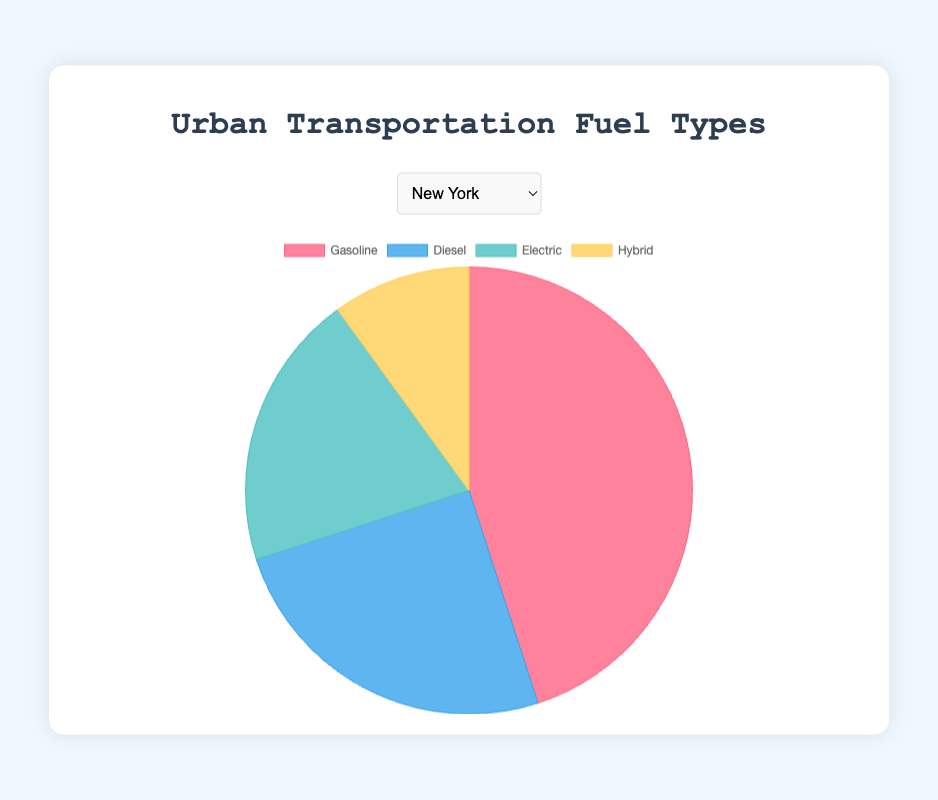Which city has the highest percentage of electric vehicles? By looking at the pie charts, we can observe the segment labeled "Electric." San Francisco has the highest percentage at 30%.
Answer: San Francisco Which city has the smallest proportion of diesel vehicles? By analyzing the pie charts, we see that the "Diesel" segment in San Francisco is the smallest at 10%.
Answer: San Francisco How does the percentage of hybrid vehicles in Los Angeles compare to that of New York? The Los Angeles pie chart shows 15% hybrid vehicles, while the New York chart shows 10%. Thus, Los Angeles has a higher percentage of hybrid vehicles than New York.
Answer: Los Angeles has a higher percentage What is the combined percentage of electric and hybrid vehicles in Chicago? The Chicago pie chart shows electric vehicles at 18% and hybrid vehicles at 12%. Adding these together, the combined percentage is 18% + 12% = 30%.
Answer: 30% Which city has the highest reliance on gasoline vehicles? By examining all the pie charts, Houston has the highest percentage of gasoline vehicles at 55%.
Answer: Houston Which cities have the same percentage of hybrid vehicles? Both Los Angeles and Houston show a 15% share for hybrid vehicles in their pie charts.
Answer: Los Angeles and Houston Calculate the average percentage of electric vehicles across all five cities. The percentages of electric vehicles in the five cities are as follows: 20% (New York), 15% (Los Angeles), 18% (Chicago), 12% (Houston), and 30% (San Francisco). (20 + 15 + 18 + 12 + 30) / 5 = 19%.
Answer: 19% What is the total percentage of hybrid vehicles in New York and San Francisco combined? The pie charts show 10% hybrid vehicles in New York and 20% in San Francisco. Adding these together, we get 10% + 20% = 30%.
Answer: 30% Which city has the lowest percentage of electric vehicles? By looking at the pie charts, we see that Houston has the lowest percentage of electric vehicles at 12%.
Answer: Houston Compare the percentage of diesel vehicles in Chicago to that of New York. Which city has a higher percentage? The chart for Chicago shows 22% diesel vehicles, while New York shows 25%. Therefore, New York has a higher percentage of diesel vehicles than Chicago.
Answer: New York 